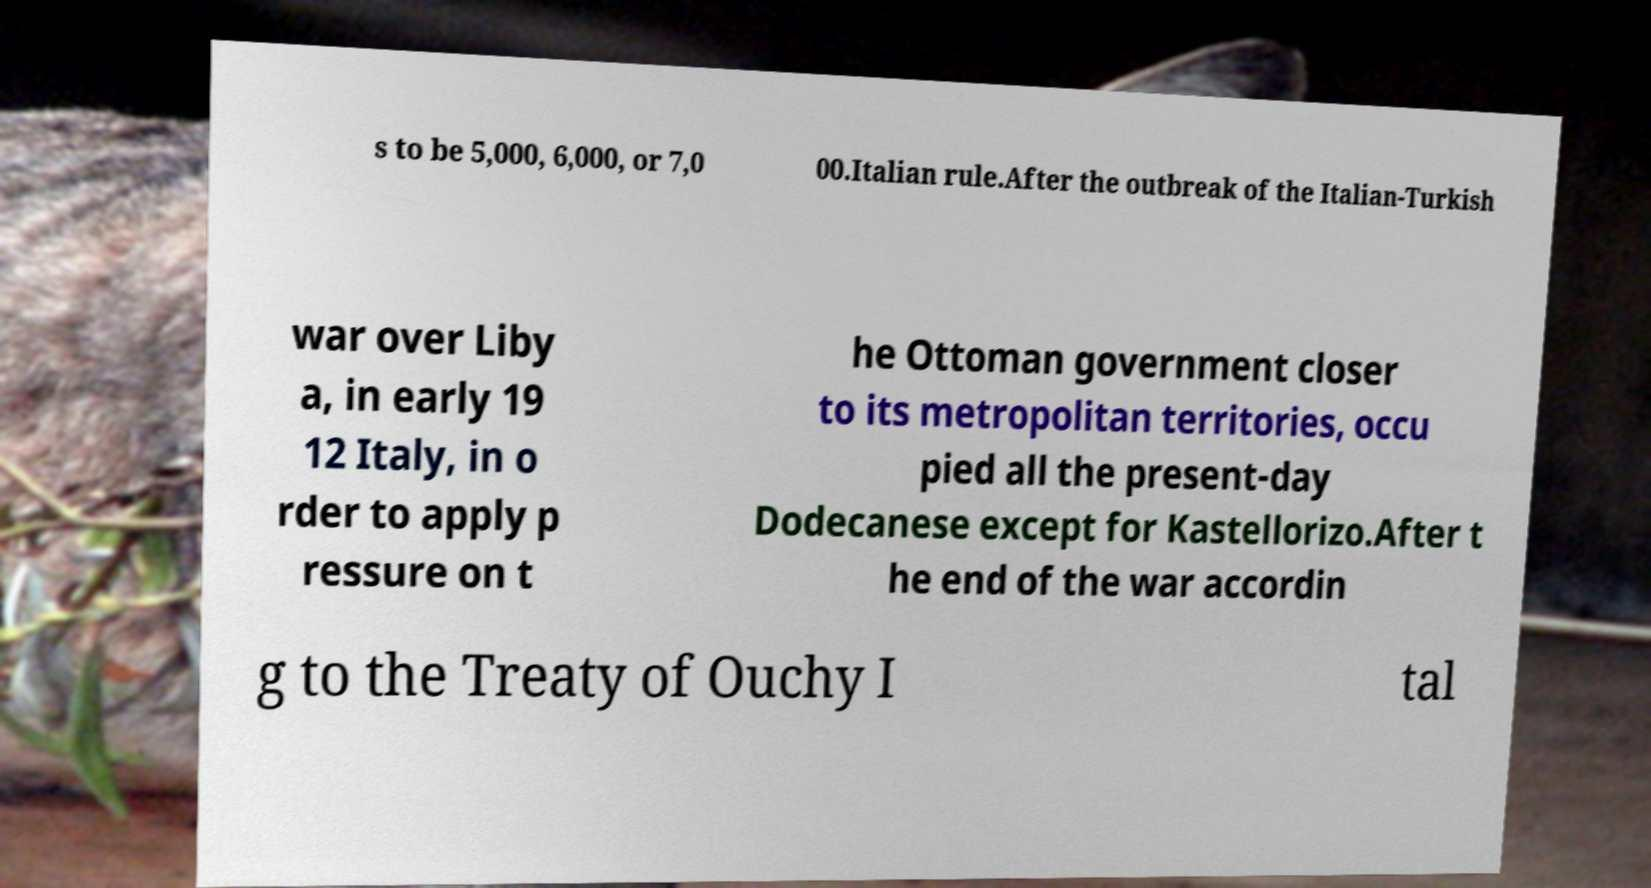What messages or text are displayed in this image? I need them in a readable, typed format. s to be 5,000, 6,000, or 7,0 00.Italian rule.After the outbreak of the Italian-Turkish war over Liby a, in early 19 12 Italy, in o rder to apply p ressure on t he Ottoman government closer to its metropolitan territories, occu pied all the present-day Dodecanese except for Kastellorizo.After t he end of the war accordin g to the Treaty of Ouchy I tal 